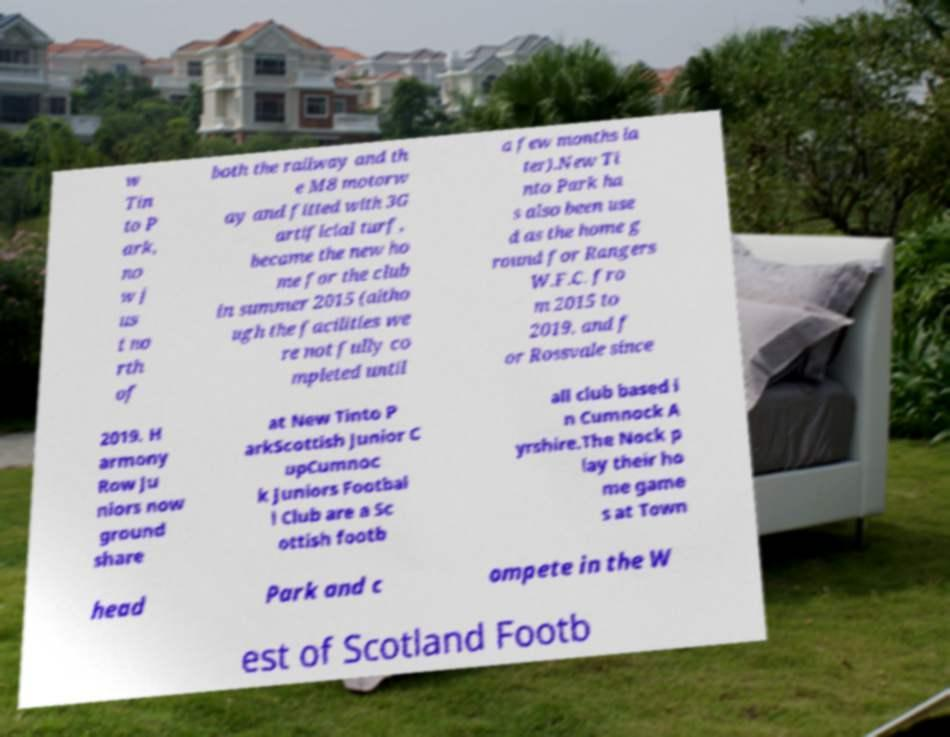There's text embedded in this image that I need extracted. Can you transcribe it verbatim? w Tin to P ark, no w j us t no rth of both the railway and th e M8 motorw ay and fitted with 3G artificial turf, became the new ho me for the club in summer 2015 (altho ugh the facilities we re not fully co mpleted until a few months la ter).New Ti nto Park ha s also been use d as the home g round for Rangers W.F.C. fro m 2015 to 2019, and f or Rossvale since 2019. H armony Row Ju niors now ground share at New Tinto P arkScottish Junior C upCumnoc k Juniors Footbal l Club are a Sc ottish footb all club based i n Cumnock A yrshire.The Nock p lay their ho me game s at Town head Park and c ompete in the W est of Scotland Footb 